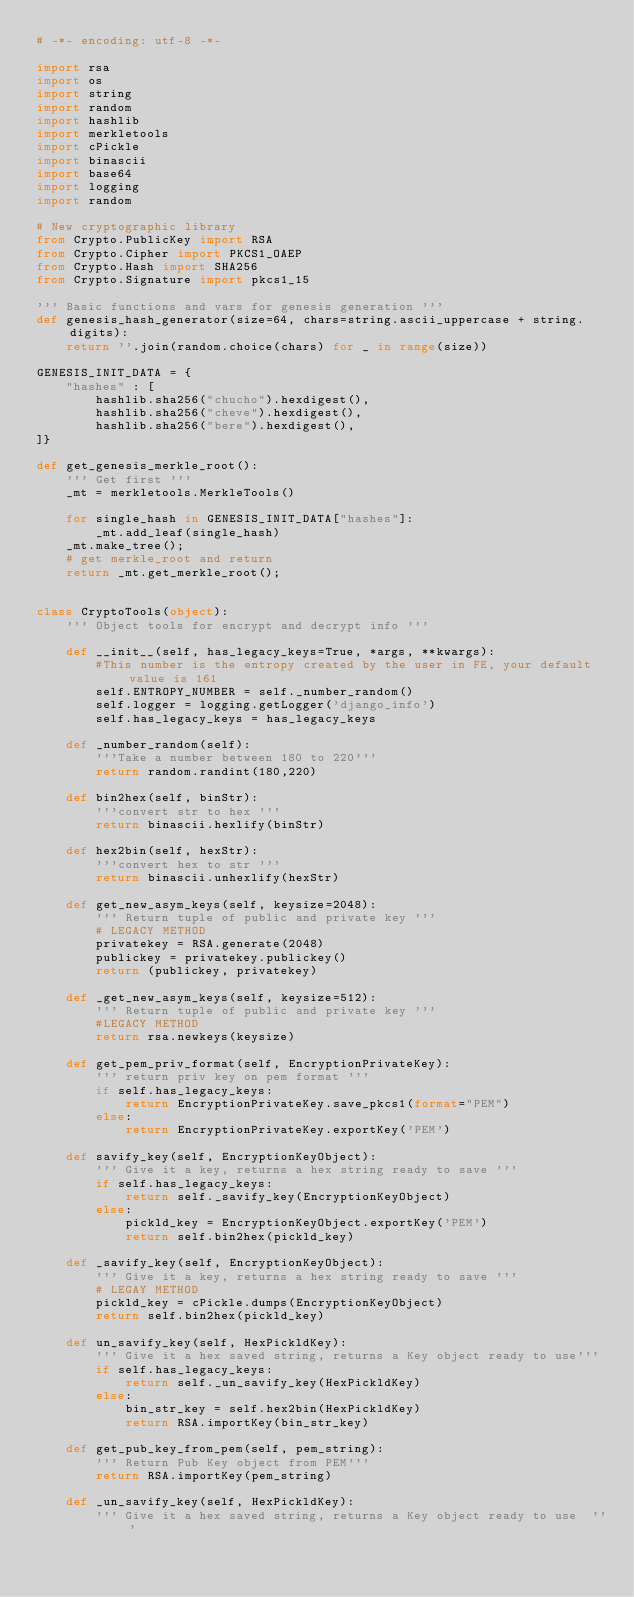<code> <loc_0><loc_0><loc_500><loc_500><_Python_># -*- encoding: utf-8 -*-

import rsa
import os
import string
import random
import hashlib
import merkletools
import cPickle
import binascii
import base64
import logging
import random

# New cryptographic library
from Crypto.PublicKey import RSA
from Crypto.Cipher import PKCS1_OAEP
from Crypto.Hash import SHA256
from Crypto.Signature import pkcs1_15

''' Basic functions and vars for genesis generation '''
def genesis_hash_generator(size=64, chars=string.ascii_uppercase + string.digits):
    return ''.join(random.choice(chars) for _ in range(size))

GENESIS_INIT_DATA = {
    "hashes" : [
        hashlib.sha256("chucho").hexdigest(),
        hashlib.sha256("cheve").hexdigest(),
        hashlib.sha256("bere").hexdigest(),
]}

def get_genesis_merkle_root():
    ''' Get first '''
    _mt = merkletools.MerkleTools()

    for single_hash in GENESIS_INIT_DATA["hashes"]:
        _mt.add_leaf(single_hash)
    _mt.make_tree();
    # get merkle_root and return
    return _mt.get_merkle_root();


class CryptoTools(object):
    ''' Object tools for encrypt and decrypt info '''

    def __init__(self, has_legacy_keys=True, *args, **kwargs):
        #This number is the entropy created by the user in FE, your default value is 161
        self.ENTROPY_NUMBER = self._number_random()
        self.logger = logging.getLogger('django_info')
        self.has_legacy_keys = has_legacy_keys

    def _number_random(self):
        '''Take a number between 180 to 220'''
        return random.randint(180,220)

    def bin2hex(self, binStr):
        '''convert str to hex '''
        return binascii.hexlify(binStr)

    def hex2bin(self, hexStr):
        '''convert hex to str '''
        return binascii.unhexlify(hexStr)

    def get_new_asym_keys(self, keysize=2048):
        ''' Return tuple of public and private key '''
        # LEGACY METHOD
        privatekey = RSA.generate(2048)
        publickey = privatekey.publickey()
        return (publickey, privatekey)

    def _get_new_asym_keys(self, keysize=512):
        ''' Return tuple of public and private key '''
        #LEGACY METHOD
        return rsa.newkeys(keysize)

    def get_pem_priv_format(self, EncryptionPrivateKey):
        ''' return priv key on pem format '''
        if self.has_legacy_keys:
            return EncryptionPrivateKey.save_pkcs1(format="PEM")
        else:
            return EncryptionPrivateKey.exportKey('PEM')

    def savify_key(self, EncryptionKeyObject):
        ''' Give it a key, returns a hex string ready to save '''
        if self.has_legacy_keys:
            return self._savify_key(EncryptionKeyObject)
        else:
            pickld_key = EncryptionKeyObject.exportKey('PEM')
            return self.bin2hex(pickld_key)

    def _savify_key(self, EncryptionKeyObject):
        ''' Give it a key, returns a hex string ready to save '''
        # LEGAY METHOD
        pickld_key = cPickle.dumps(EncryptionKeyObject)
        return self.bin2hex(pickld_key)

    def un_savify_key(self, HexPickldKey):
        ''' Give it a hex saved string, returns a Key object ready to use'''
        if self.has_legacy_keys:
            return self._un_savify_key(HexPickldKey)
        else:
            bin_str_key = self.hex2bin(HexPickldKey)
            return RSA.importKey(bin_str_key)

    def get_pub_key_from_pem(self, pem_string):
        ''' Return Pub Key object from PEM'''
        return RSA.importKey(pem_string)

    def _un_savify_key(self, HexPickldKey):
        ''' Give it a hex saved string, returns a Key object ready to use  '''</code> 